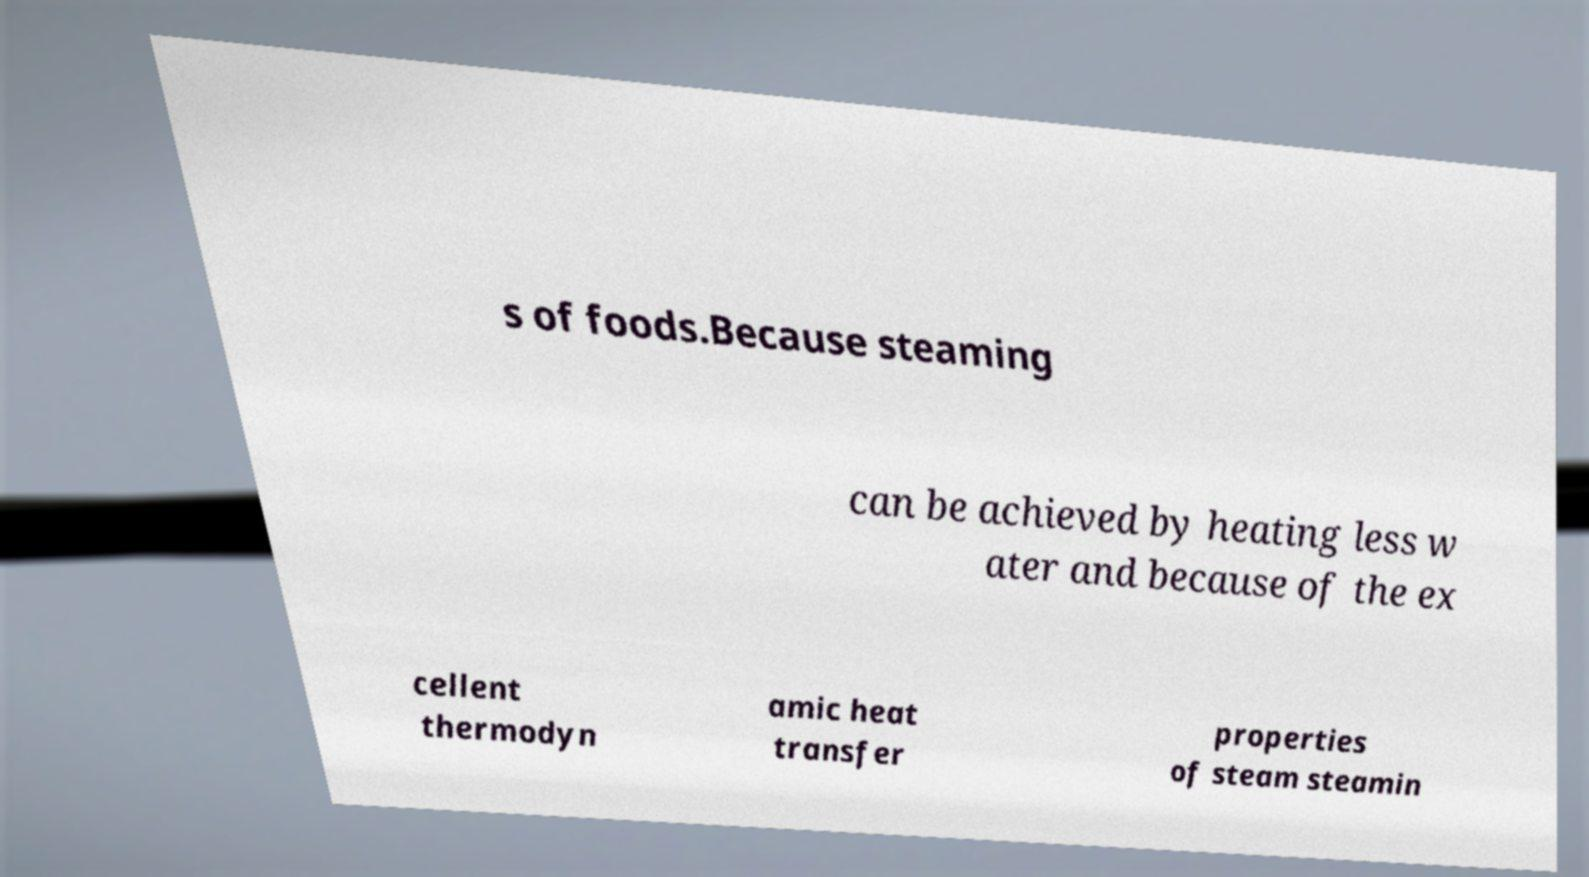Could you extract and type out the text from this image? s of foods.Because steaming can be achieved by heating less w ater and because of the ex cellent thermodyn amic heat transfer properties of steam steamin 